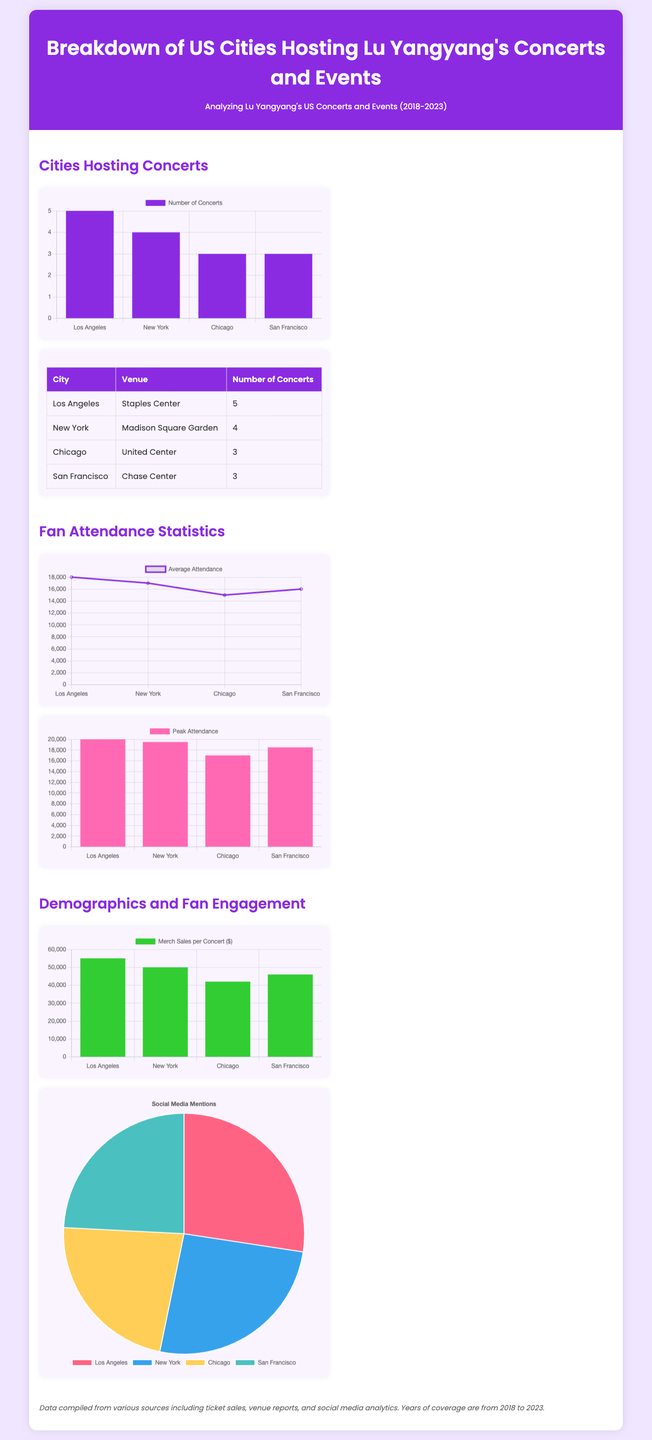what city hosted the most concerts? The city with the highest number of concerts is Los Angeles with 5 concerts.
Answer: Los Angeles how many concerts were held in New York? The number of concerts held in New York is 4.
Answer: 4 what was the average attendance in Chicago? The average attendance in Chicago was 15000 according to the attendance statistics.
Answer: 15000 which city had the highest peak attendance? Los Angeles had the highest peak attendance of 20000.
Answer: Los Angeles what was the merchandise sales per concert in San Francisco? The merchandise sales per concert in San Francisco were $46000.
Answer: $46000 which chart shows social media mentions? The pie chart displays the social media mentions.
Answer: pie chart how many concerts were held in total across the listed cities? The total number of concerts is 15 (5 + 4 + 3 + 3).
Answer: 15 what was the peak attendance for New York? The peak attendance for New York was 19500.
Answer: 19500 which venue hosted Lu Yangyang's concerts in Chicago? United Center hosted Lu Yangyang's concerts in Chicago.
Answer: United Center 